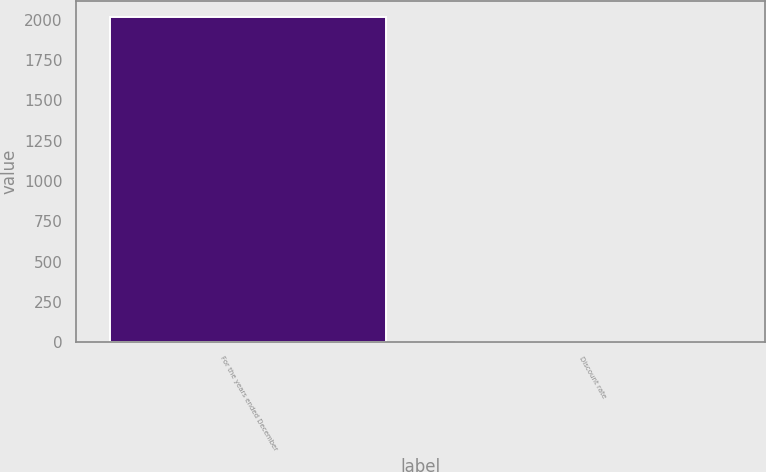Convert chart. <chart><loc_0><loc_0><loc_500><loc_500><bar_chart><fcel>For the years ended December<fcel>Discount rate<nl><fcel>2014<fcel>4.5<nl></chart> 